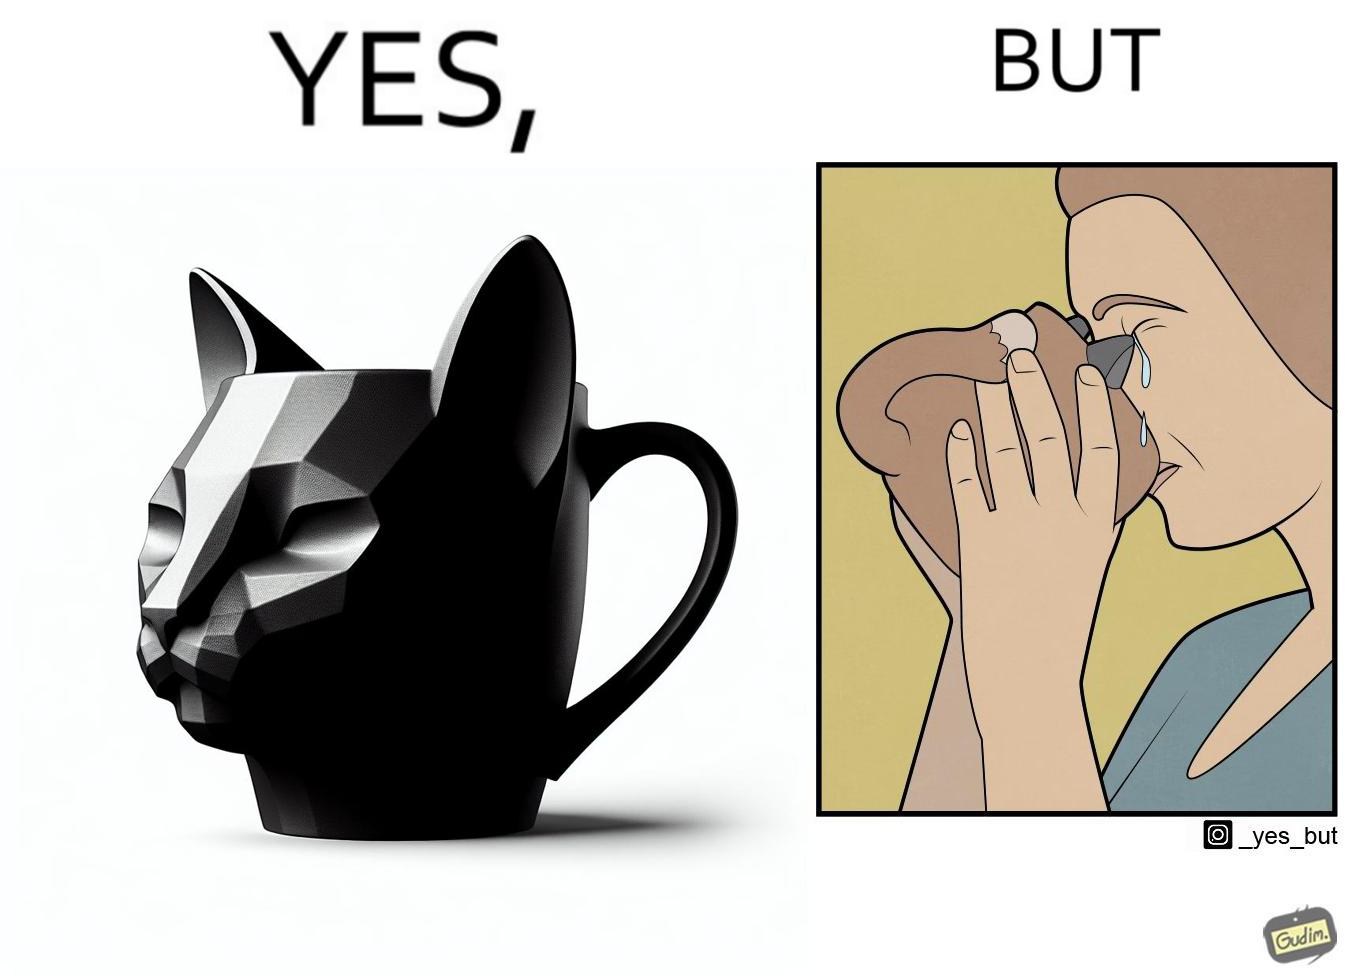What is shown in the left half versus the right half of this image? In the left part of the image: A mug that looks like a cat's face and has cat's facial features like ears In the right part of the image: a woman drinking from a mug and crying because something on the mug is poking in her face 